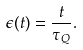<formula> <loc_0><loc_0><loc_500><loc_500>\epsilon ( t ) = \frac { t } { \tau _ { Q } } .</formula> 